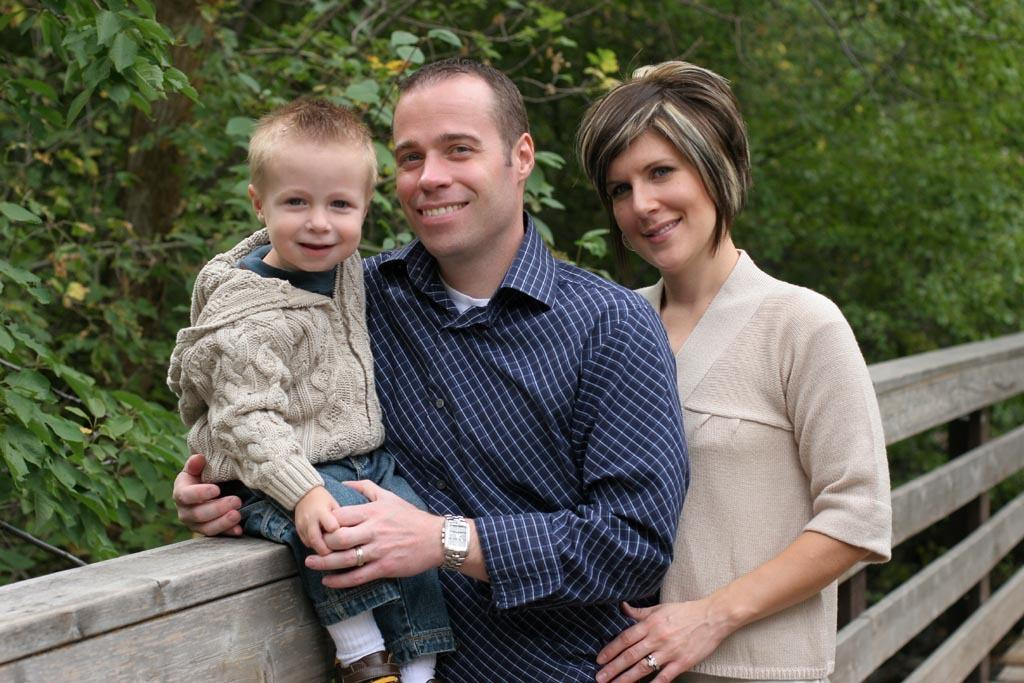How many people are in the image? There are three persons in the image. Can you describe the gender of each person? One of the persons is a woman, one is a man, and one is a boy. What are the persons doing in the image? The three persons are sitting on a fence. What is the facial expression of the persons? The persons are smiling. What can be seen in the background of the image? There are trees visible in the background of the image. What type of blood is visible on the fence in the image? There is no blood visible on the fence in the image. Can you tell me how many ducks are sitting on the fence with the persons? There are no ducks present in the image; only the three persons are sitting on the fence. 